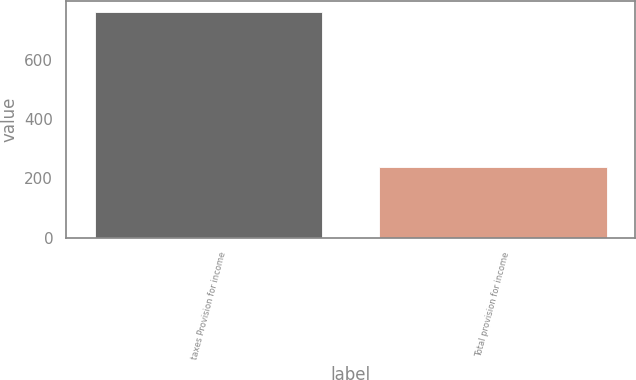Convert chart to OTSL. <chart><loc_0><loc_0><loc_500><loc_500><bar_chart><fcel>taxes Provision for income<fcel>Total provision for income<nl><fcel>761<fcel>238.6<nl></chart> 